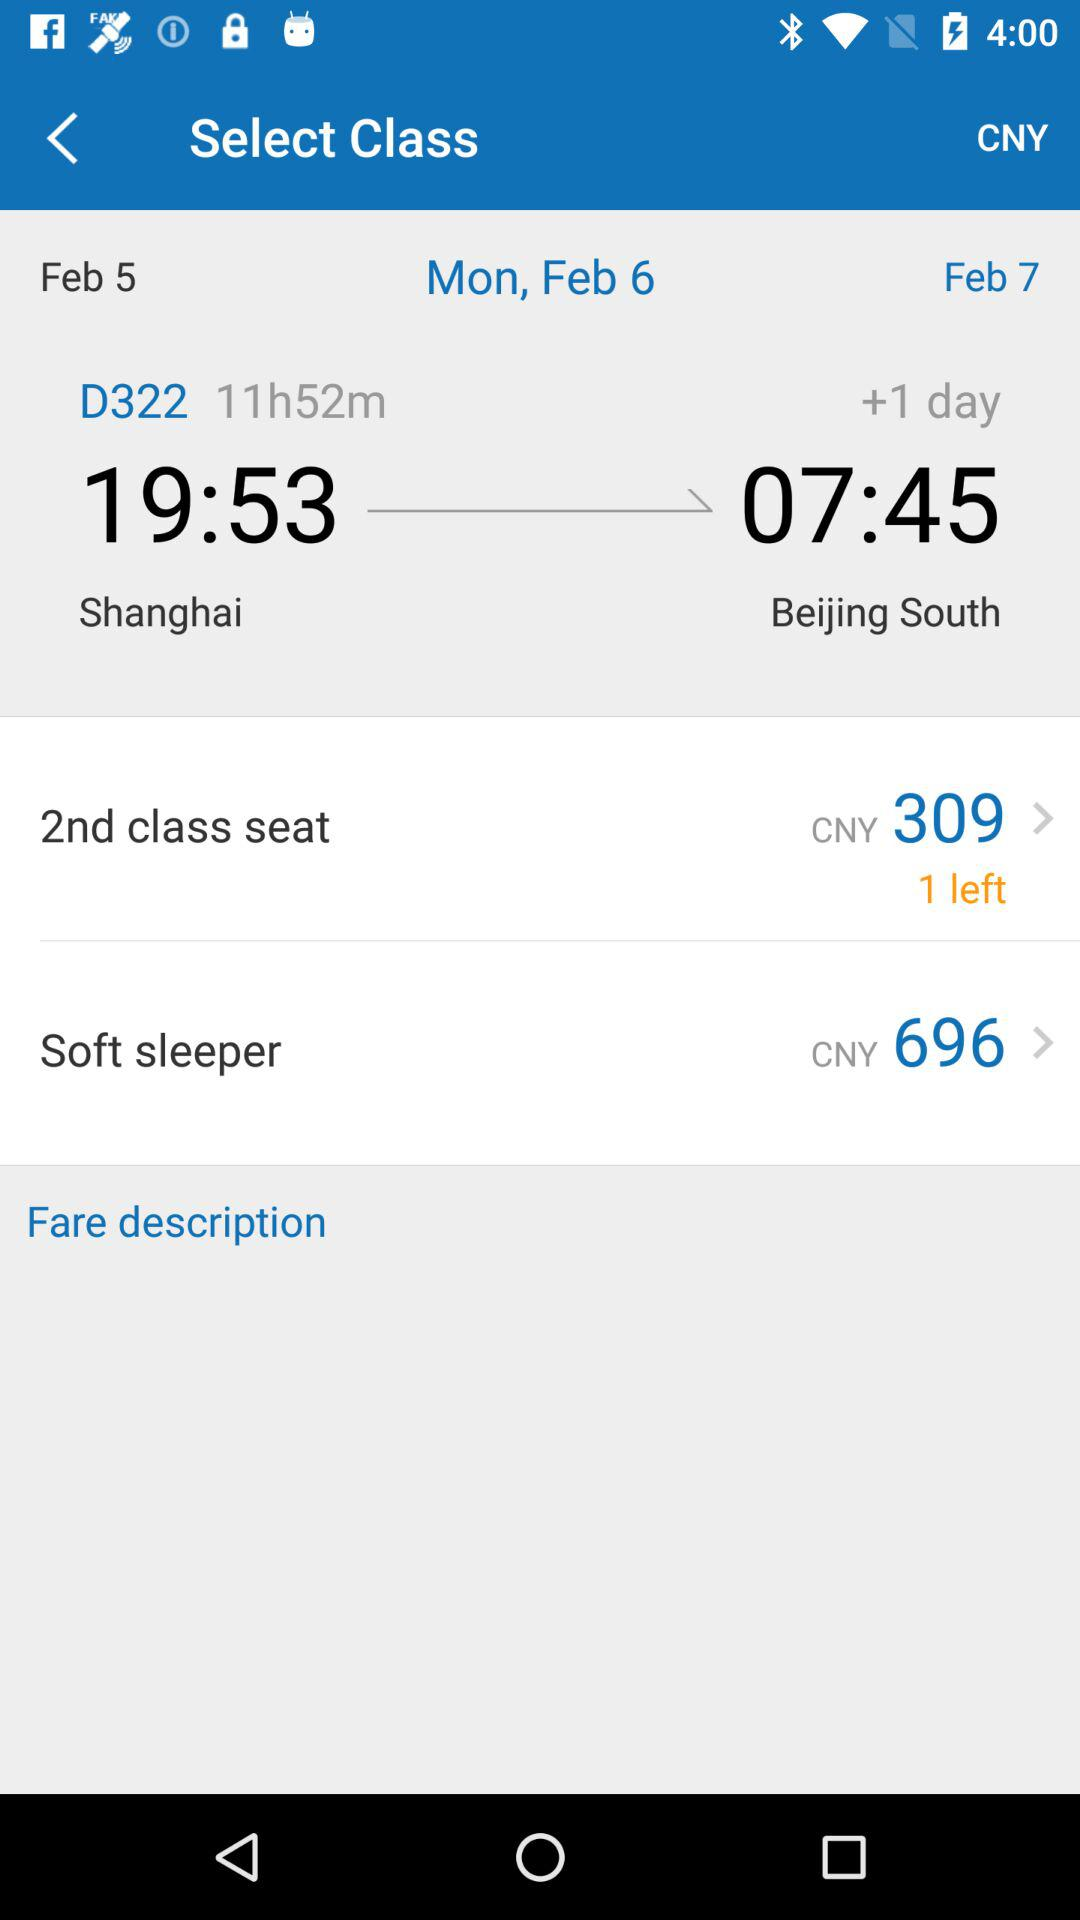How much time will the flight take? The flight will take 11 hours 52 minutes. 